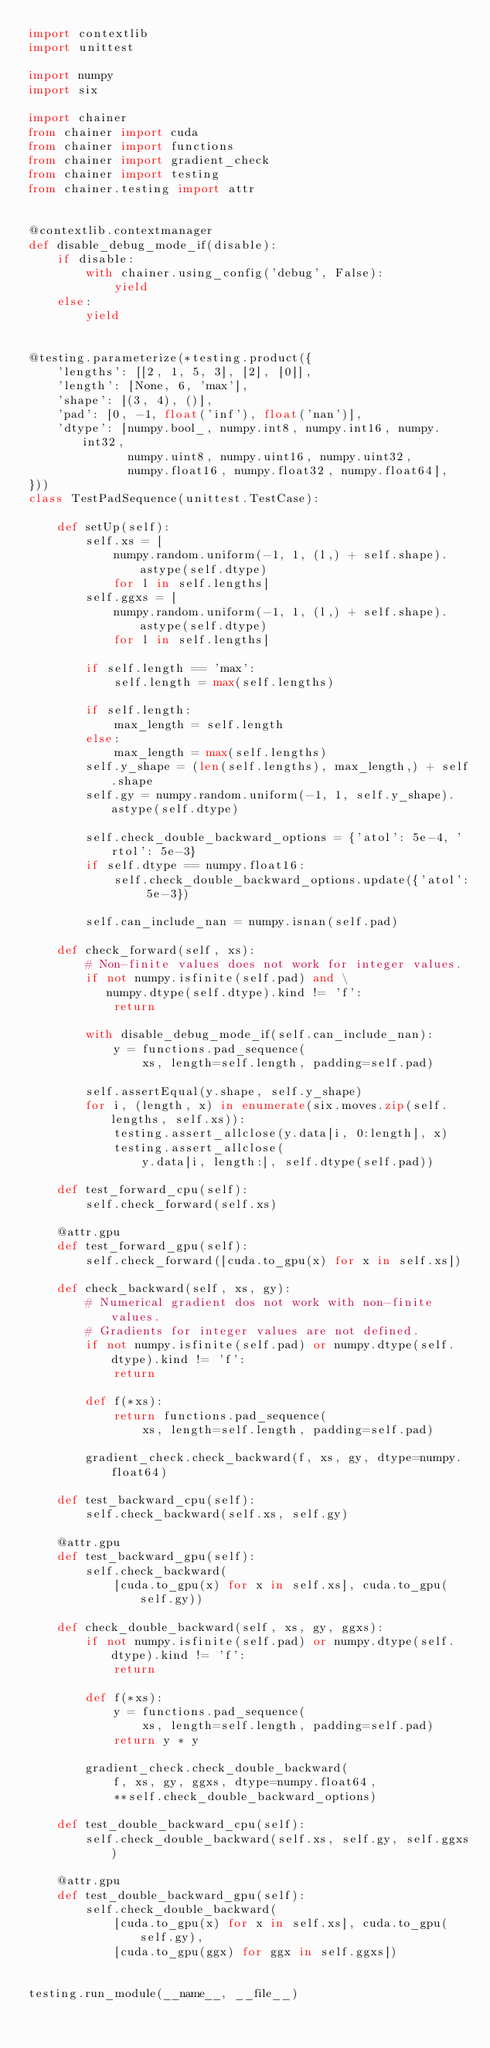<code> <loc_0><loc_0><loc_500><loc_500><_Python_>import contextlib
import unittest

import numpy
import six

import chainer
from chainer import cuda
from chainer import functions
from chainer import gradient_check
from chainer import testing
from chainer.testing import attr


@contextlib.contextmanager
def disable_debug_mode_if(disable):
    if disable:
        with chainer.using_config('debug', False):
            yield
    else:
        yield


@testing.parameterize(*testing.product({
    'lengths': [[2, 1, 5, 3], [2], [0]],
    'length': [None, 6, 'max'],
    'shape': [(3, 4), ()],
    'pad': [0, -1, float('inf'), float('nan')],
    'dtype': [numpy.bool_, numpy.int8, numpy.int16, numpy.int32,
              numpy.uint8, numpy.uint16, numpy.uint32,
              numpy.float16, numpy.float32, numpy.float64],
}))
class TestPadSequence(unittest.TestCase):

    def setUp(self):
        self.xs = [
            numpy.random.uniform(-1, 1, (l,) + self.shape).astype(self.dtype)
            for l in self.lengths]
        self.ggxs = [
            numpy.random.uniform(-1, 1, (l,) + self.shape).astype(self.dtype)
            for l in self.lengths]

        if self.length == 'max':
            self.length = max(self.lengths)

        if self.length:
            max_length = self.length
        else:
            max_length = max(self.lengths)
        self.y_shape = (len(self.lengths), max_length,) + self.shape
        self.gy = numpy.random.uniform(-1, 1, self.y_shape).astype(self.dtype)

        self.check_double_backward_options = {'atol': 5e-4, 'rtol': 5e-3}
        if self.dtype == numpy.float16:
            self.check_double_backward_options.update({'atol': 5e-3})

        self.can_include_nan = numpy.isnan(self.pad)

    def check_forward(self, xs):
        # Non-finite values does not work for integer values.
        if not numpy.isfinite(self.pad) and \
           numpy.dtype(self.dtype).kind != 'f':
            return

        with disable_debug_mode_if(self.can_include_nan):
            y = functions.pad_sequence(
                xs, length=self.length, padding=self.pad)

        self.assertEqual(y.shape, self.y_shape)
        for i, (length, x) in enumerate(six.moves.zip(self.lengths, self.xs)):
            testing.assert_allclose(y.data[i, 0:length], x)
            testing.assert_allclose(
                y.data[i, length:], self.dtype(self.pad))

    def test_forward_cpu(self):
        self.check_forward(self.xs)

    @attr.gpu
    def test_forward_gpu(self):
        self.check_forward([cuda.to_gpu(x) for x in self.xs])

    def check_backward(self, xs, gy):
        # Numerical gradient dos not work with non-finite values.
        # Gradients for integer values are not defined.
        if not numpy.isfinite(self.pad) or numpy.dtype(self.dtype).kind != 'f':
            return

        def f(*xs):
            return functions.pad_sequence(
                xs, length=self.length, padding=self.pad)

        gradient_check.check_backward(f, xs, gy, dtype=numpy.float64)

    def test_backward_cpu(self):
        self.check_backward(self.xs, self.gy)

    @attr.gpu
    def test_backward_gpu(self):
        self.check_backward(
            [cuda.to_gpu(x) for x in self.xs], cuda.to_gpu(self.gy))

    def check_double_backward(self, xs, gy, ggxs):
        if not numpy.isfinite(self.pad) or numpy.dtype(self.dtype).kind != 'f':
            return

        def f(*xs):
            y = functions.pad_sequence(
                xs, length=self.length, padding=self.pad)
            return y * y

        gradient_check.check_double_backward(
            f, xs, gy, ggxs, dtype=numpy.float64,
            **self.check_double_backward_options)

    def test_double_backward_cpu(self):
        self.check_double_backward(self.xs, self.gy, self.ggxs)

    @attr.gpu
    def test_double_backward_gpu(self):
        self.check_double_backward(
            [cuda.to_gpu(x) for x in self.xs], cuda.to_gpu(self.gy),
            [cuda.to_gpu(ggx) for ggx in self.ggxs])


testing.run_module(__name__, __file__)
</code> 